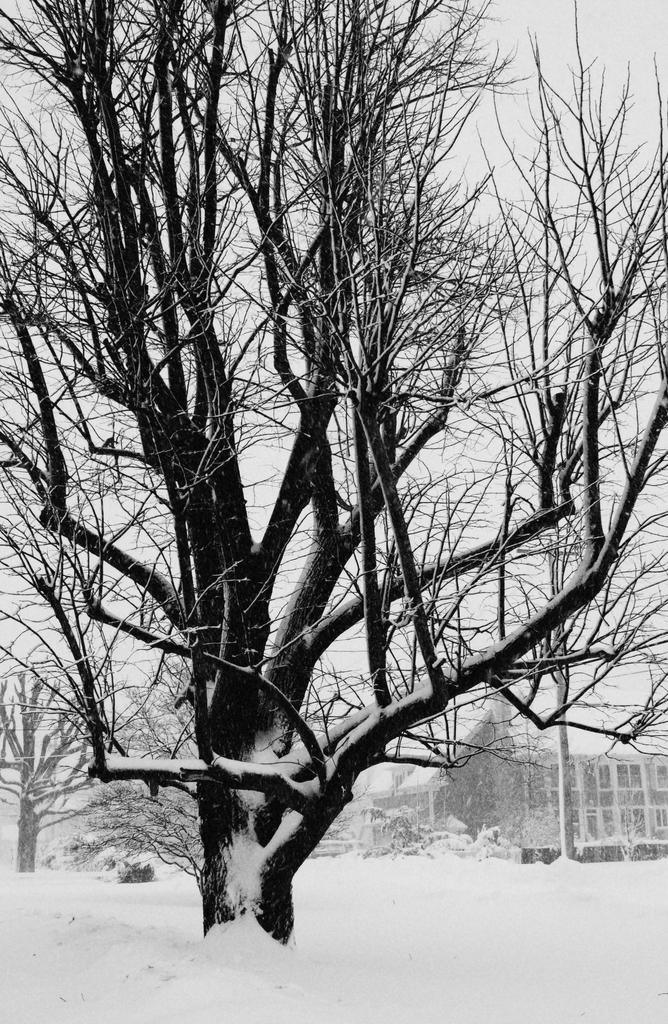What type of weather condition is depicted in the image? There is snow in the image, indicating a cold or wintry weather condition. What type of natural elements can be seen in the image? There are trees in the image. What structures can be seen in the background of the image? There is a building and a pole in the background of the image. What is visible in the sky in the image? The sky is visible in the background of the image. What type of flower is growing on the pole in the image? There is no flower growing on the pole in the image; it is a pole without any floral elements. 